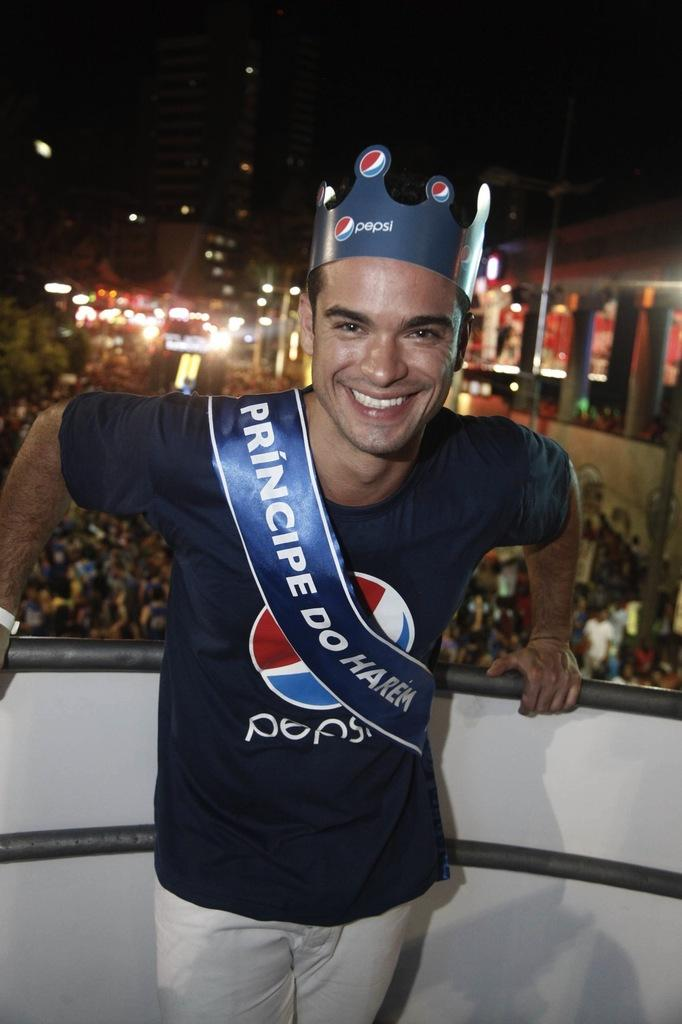Provide a one-sentence caption for the provided image. The gentleman in Pepsi attire looks very happy with himself. 